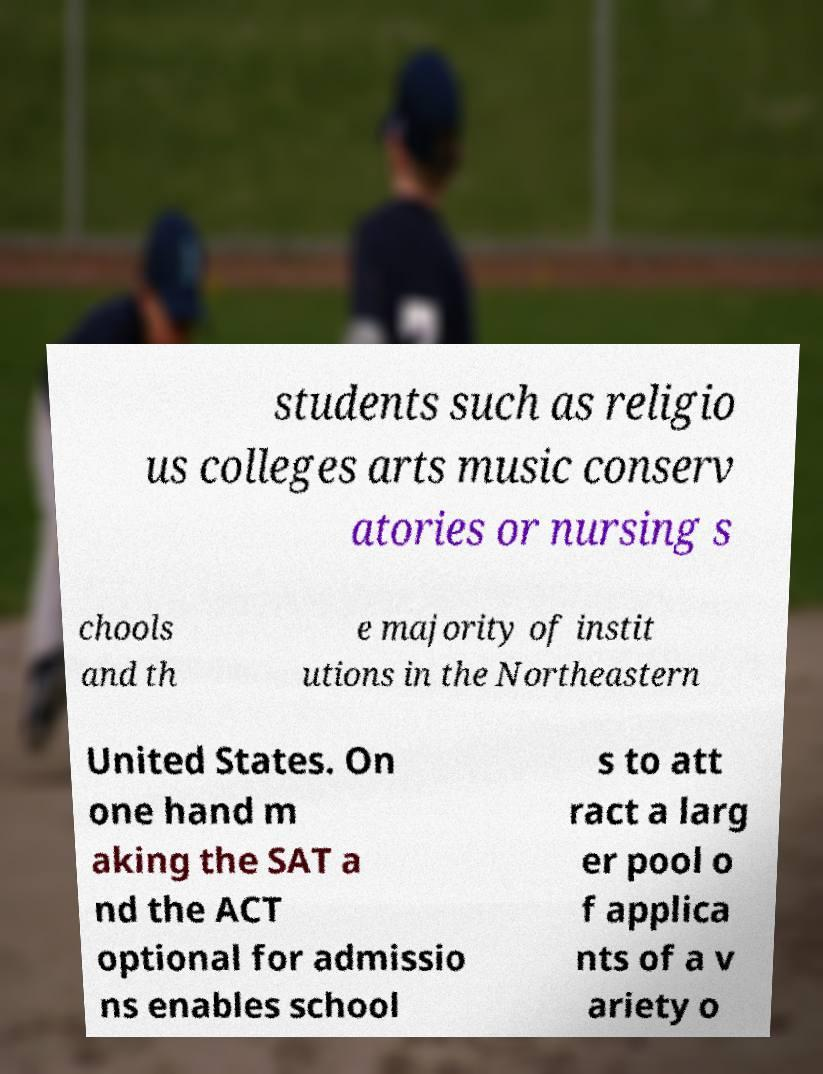I need the written content from this picture converted into text. Can you do that? students such as religio us colleges arts music conserv atories or nursing s chools and th e majority of instit utions in the Northeastern United States. On one hand m aking the SAT a nd the ACT optional for admissio ns enables school s to att ract a larg er pool o f applica nts of a v ariety o 